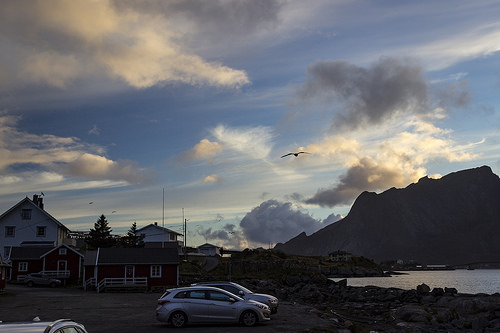<image>
Is the bird in the lake? No. The bird is not contained within the lake. These objects have a different spatial relationship. 